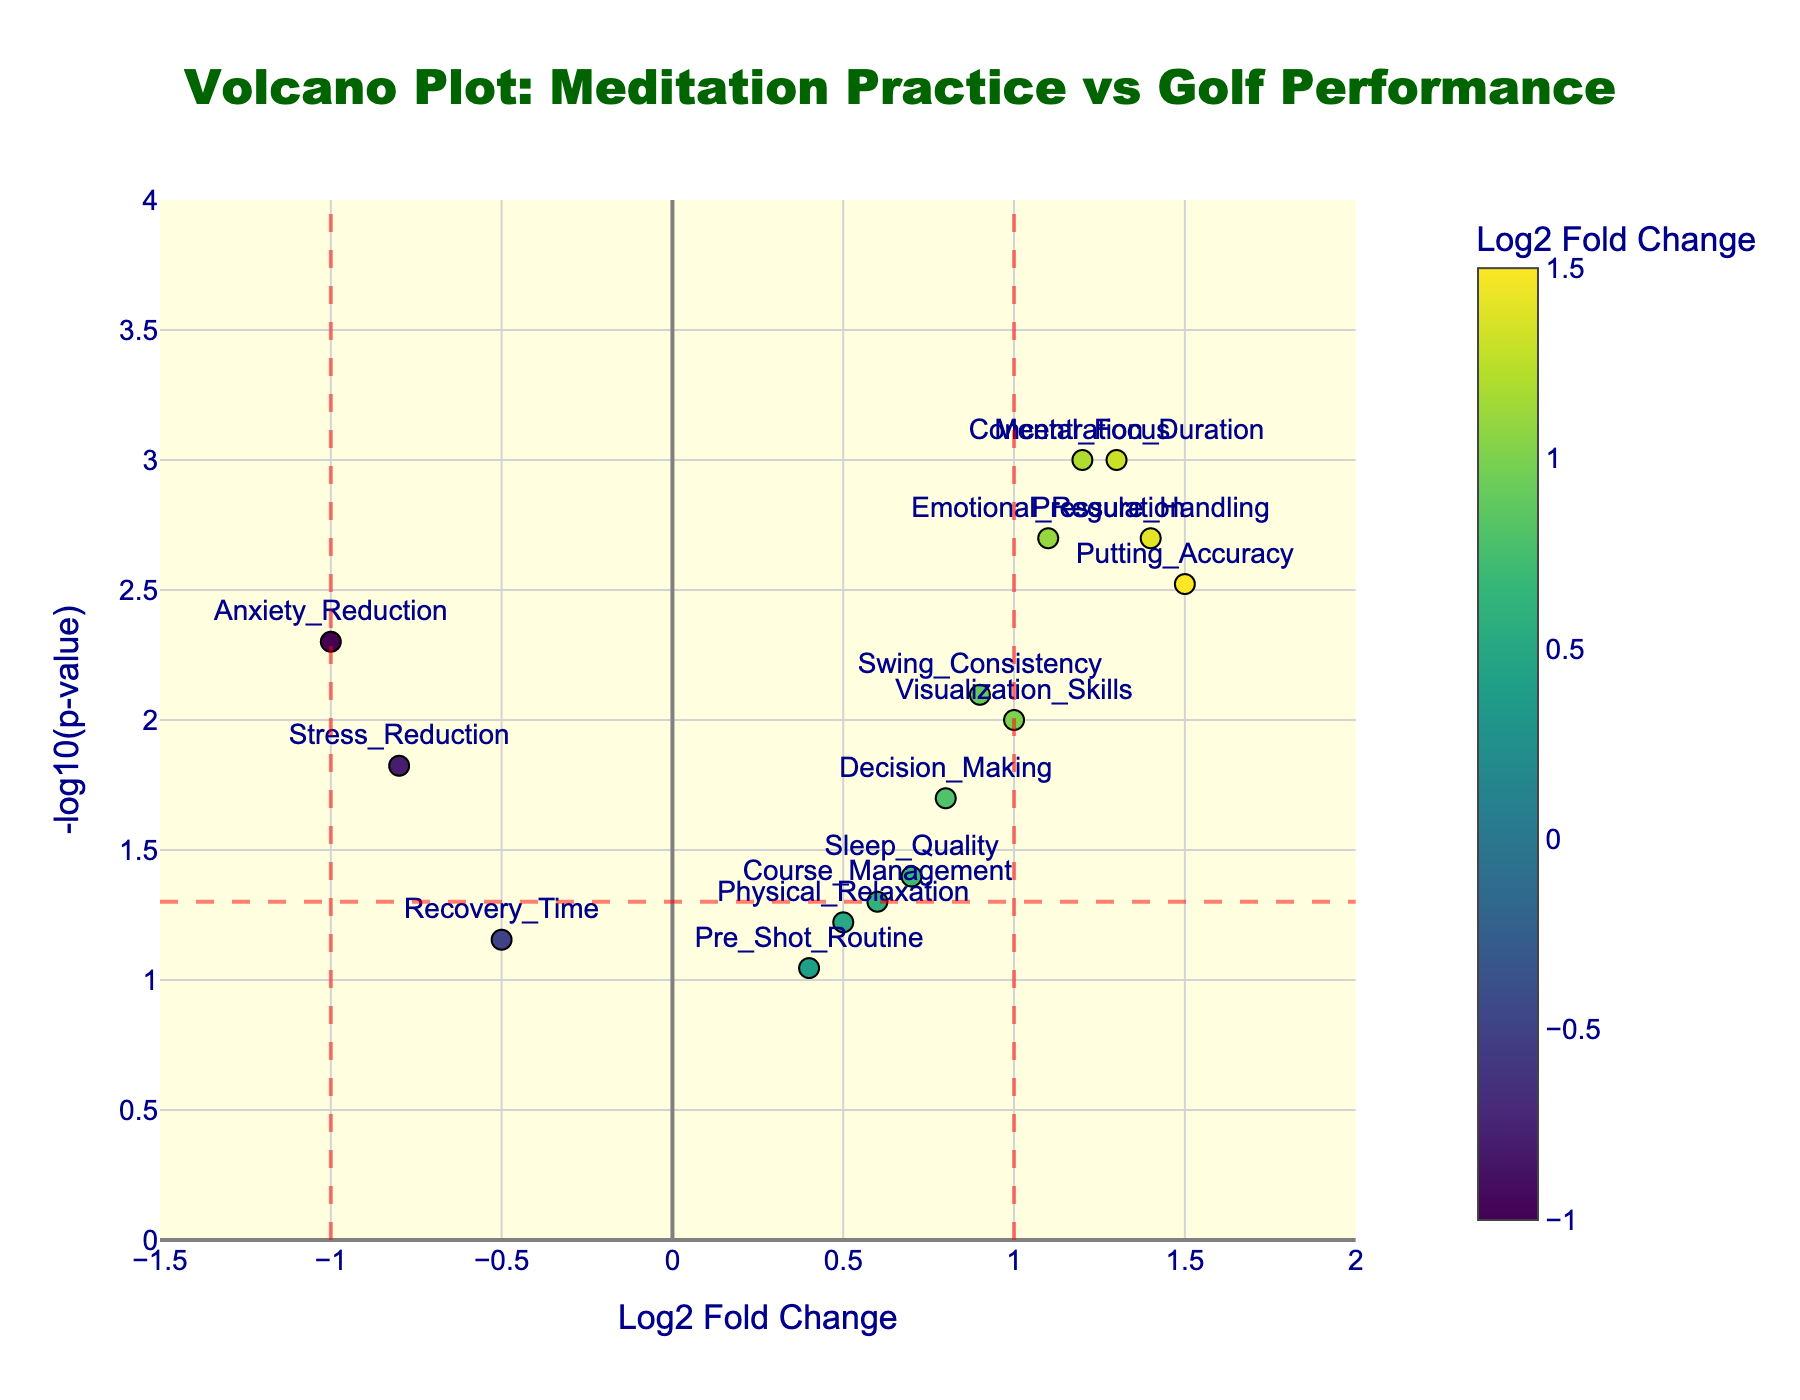How many data points are there in the figure? By counting the number of markers in the volcano plot, we can determine the number of data points. Each point represents a different gene's performance metric.
Answer: 15 Which gene has the highest -log10(p-value)? Looking at the y-axis for the highest point, the gene label at the top will show the gene with the highest -log10(p-value).
Answer: Concentration_Duration Which gene showed the highest performance improvement (Log2 Fold Change)? Identify the point furthest to the right on the x-axis, which will have the highest Log2 Fold Change value.
Answer: Putting_Accuracy Which genes have a significant correlation based on the horizontal dash line at -log10(p-value) = 1.301? The horizontal dash line at -log10(p-value) = 1.301 represents p = 0.05. Genes above this line are considered significant. Look for markers above this line and identify their labels.
Answer: Mental_Focus, Stress_Reduction, Swing_Consistency, Putting_Accuracy, Emotional_Regulation, Anxiety_Reduction, Concentration_Duration, Pressure_Handling, Visualization_Skills, Decision_Making What is the Log2 Fold Change and p-value for the gene associated with Emotional_Regulation? Locate the point labeled Emotional_Regulation, then use hover text or labels to find its Log2 Fold Change and p-value.
Answer: Log2 Fold Change: 1.1, p-value: 0.002 How does the performance improvement of Sleep_Quality compare with that of Mental_Focus? Compare the Log2 Fold Change values for Sleep_Quality and Mental_Focus. Sleep_Quality has a Log2 Fold Change of 0.7, while Mental_Focus has 1.2.
Answer: Mental_Focus has a greater performance improvement Which genes are associated with decreased performance, and how many are there? Look for points with a negative Log2 Fold Change (left side of the plot), and count these points.
Answer: Stress_Reduction, Recovery_Time, Anxiety_Reduction (3 genes) Which gene has the smallest Log2 Fold Change among those with significant p-values? First, identify the significant genes above the horizontal dash line at -log10(p-value) = 1.301. Then, among those, find the gene with the smallest Log2 Fold Change value.
Answer: Stress_Reduction If the criteria for significance were made more stringent (p < 0.01), which genes would remain significant? Identify the genes above the -log10(p-value) of 2 on the y-axis (which corresponds to p < 0.01).
Answer: Mental_Focus, Swing_Consistency, Putting_Accuracy, Emotional_Regulation, Concentration_Duration, Anxiety_Reduction, Pressure_Handling What is the impact of Pre_Shot_Routine on performance according to the plot? Locate the point labeled Pre_Shot_Routine and note its position, specifically its Log2 Fold Change and p-value.
Answer: Log2 Fold Change: 0.4, p-value: 0.09 